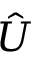Convert formula to latex. <formula><loc_0><loc_0><loc_500><loc_500>\hat { U }</formula> 